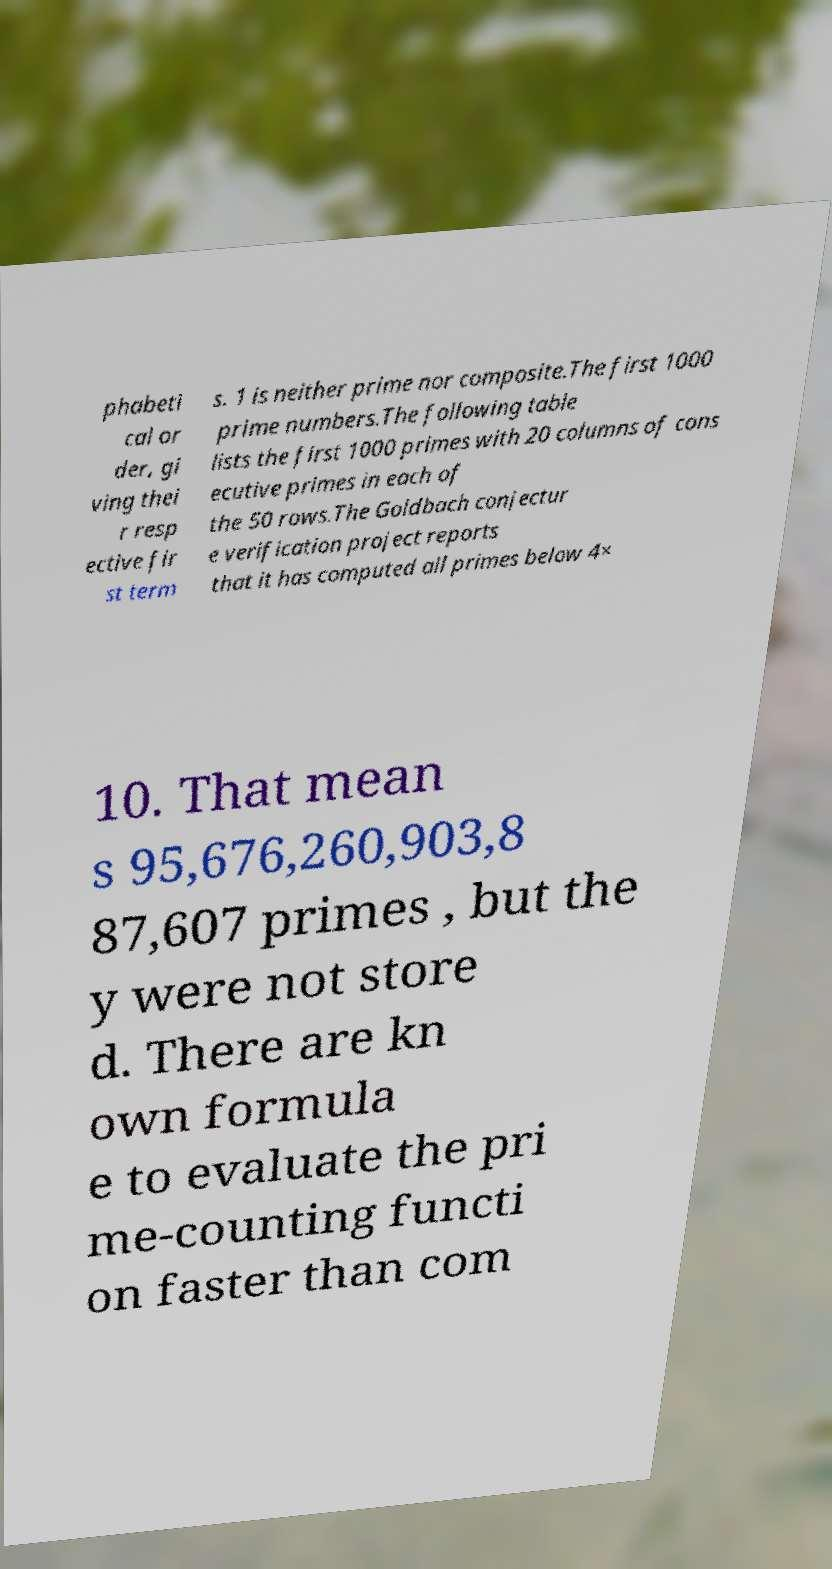I need the written content from this picture converted into text. Can you do that? phabeti cal or der, gi ving thei r resp ective fir st term s. 1 is neither prime nor composite.The first 1000 prime numbers.The following table lists the first 1000 primes with 20 columns of cons ecutive primes in each of the 50 rows.The Goldbach conjectur e verification project reports that it has computed all primes below 4× 10. That mean s 95,676,260,903,8 87,607 primes , but the y were not store d. There are kn own formula e to evaluate the pri me-counting functi on faster than com 